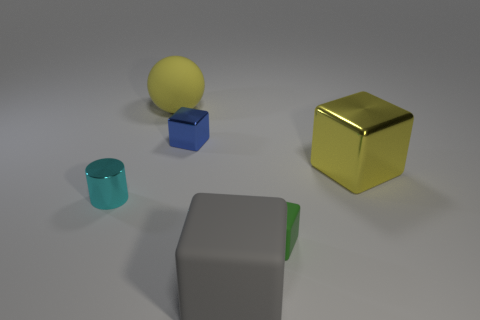Add 1 small red objects. How many objects exist? 7 Subtract all spheres. How many objects are left? 5 Subtract all small blue metal cubes. Subtract all green blocks. How many objects are left? 4 Add 2 big matte blocks. How many big matte blocks are left? 3 Add 5 tiny green matte blocks. How many tiny green matte blocks exist? 6 Subtract 0 cyan balls. How many objects are left? 6 